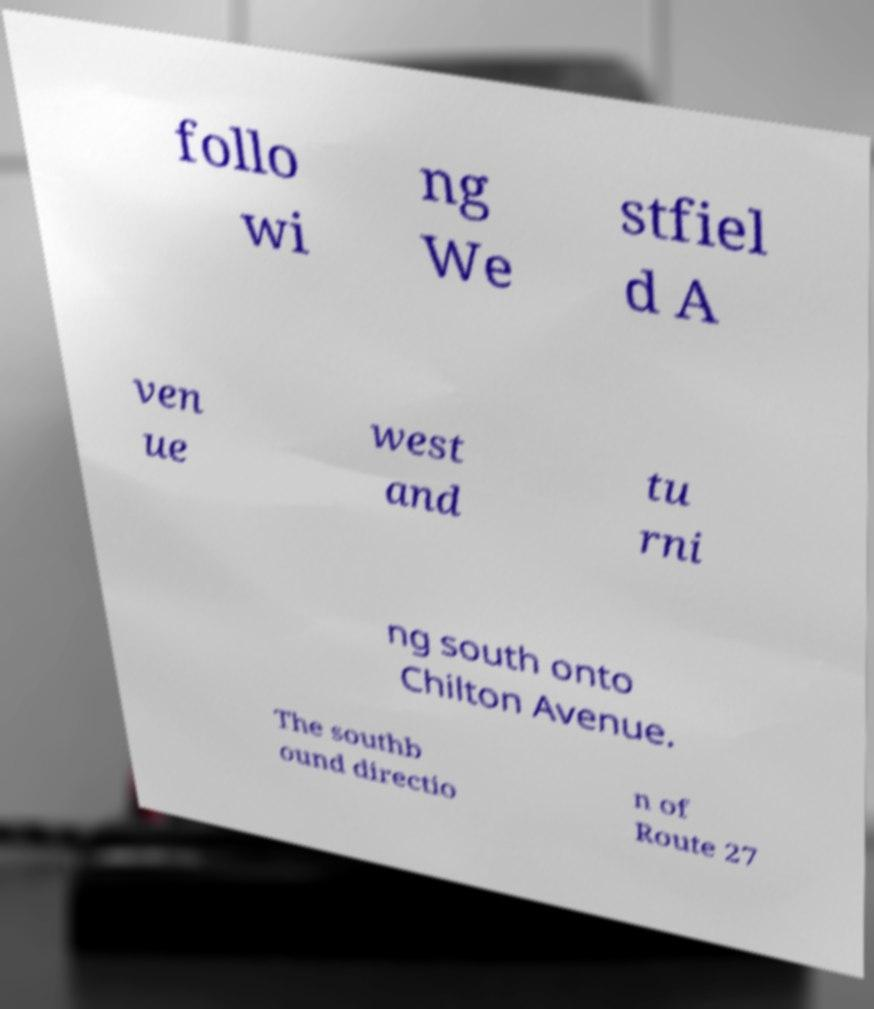Could you extract and type out the text from this image? follo wi ng We stfiel d A ven ue west and tu rni ng south onto Chilton Avenue. The southb ound directio n of Route 27 